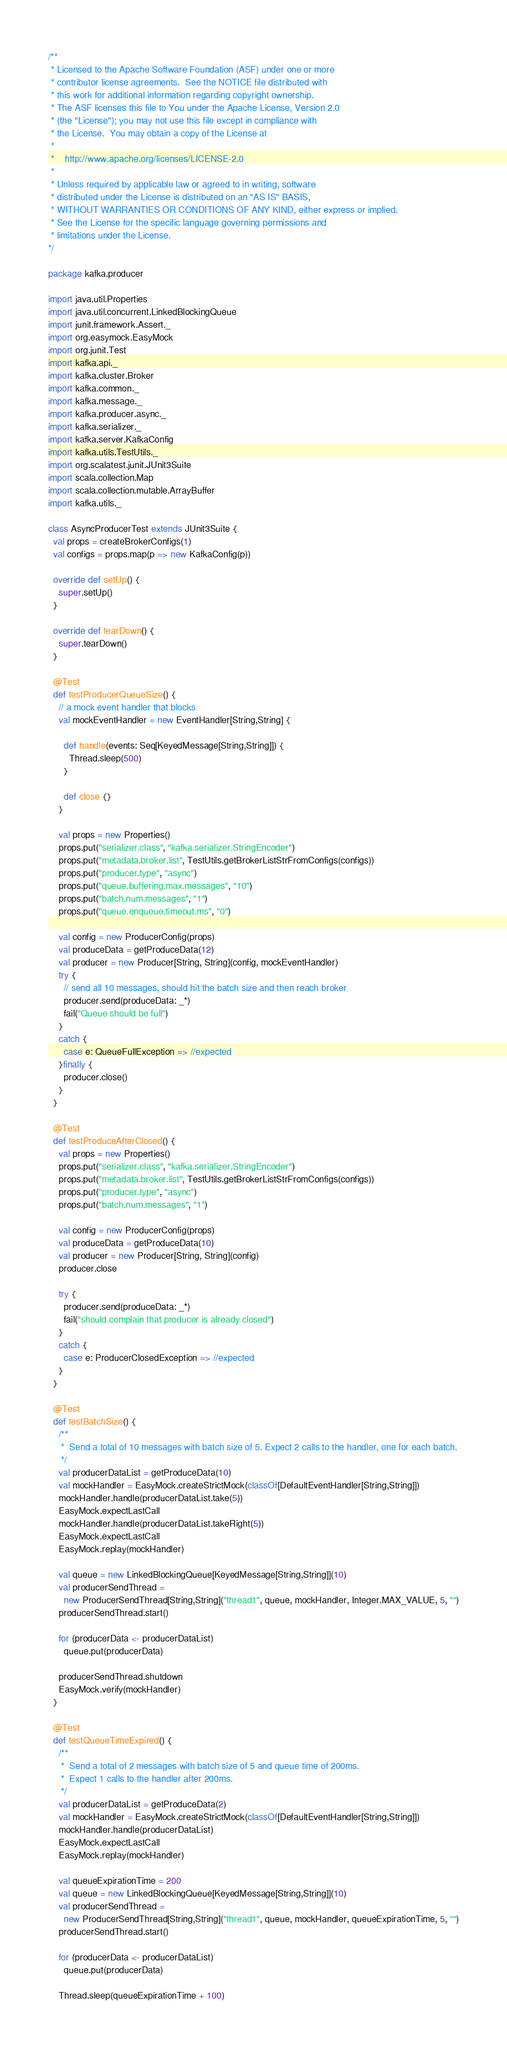Convert code to text. <code><loc_0><loc_0><loc_500><loc_500><_Scala_>/**
 * Licensed to the Apache Software Foundation (ASF) under one or more
 * contributor license agreements.  See the NOTICE file distributed with
 * this work for additional information regarding copyright ownership.
 * The ASF licenses this file to You under the Apache License, Version 2.0
 * (the "License"); you may not use this file except in compliance with
 * the License.  You may obtain a copy of the License at
 *
 *    http://www.apache.org/licenses/LICENSE-2.0
 *
 * Unless required by applicable law or agreed to in writing, software
 * distributed under the License is distributed on an "AS IS" BASIS,
 * WITHOUT WARRANTIES OR CONDITIONS OF ANY KIND, either express or implied.
 * See the License for the specific language governing permissions and
 * limitations under the License.
*/

package kafka.producer

import java.util.Properties
import java.util.concurrent.LinkedBlockingQueue
import junit.framework.Assert._
import org.easymock.EasyMock
import org.junit.Test
import kafka.api._
import kafka.cluster.Broker
import kafka.common._
import kafka.message._
import kafka.producer.async._
import kafka.serializer._
import kafka.server.KafkaConfig
import kafka.utils.TestUtils._
import org.scalatest.junit.JUnit3Suite
import scala.collection.Map
import scala.collection.mutable.ArrayBuffer
import kafka.utils._

class AsyncProducerTest extends JUnit3Suite {
  val props = createBrokerConfigs(1)
  val configs = props.map(p => new KafkaConfig(p))

  override def setUp() {
    super.setUp()
  }

  override def tearDown() {
    super.tearDown()
  }

  @Test
  def testProducerQueueSize() {
    // a mock event handler that blocks
    val mockEventHandler = new EventHandler[String,String] {

      def handle(events: Seq[KeyedMessage[String,String]]) {
        Thread.sleep(500)
      }

      def close {}
    }

    val props = new Properties()
    props.put("serializer.class", "kafka.serializer.StringEncoder")
    props.put("metadata.broker.list", TestUtils.getBrokerListStrFromConfigs(configs))
    props.put("producer.type", "async")
    props.put("queue.buffering.max.messages", "10")
    props.put("batch.num.messages", "1")
    props.put("queue.enqueue.timeout.ms", "0")

    val config = new ProducerConfig(props)
    val produceData = getProduceData(12)
    val producer = new Producer[String, String](config, mockEventHandler)
    try {
      // send all 10 messages, should hit the batch size and then reach broker
      producer.send(produceData: _*)
      fail("Queue should be full")
    }
    catch {
      case e: QueueFullException => //expected
    }finally {
      producer.close()
    }
  }

  @Test
  def testProduceAfterClosed() {
    val props = new Properties()
    props.put("serializer.class", "kafka.serializer.StringEncoder")
    props.put("metadata.broker.list", TestUtils.getBrokerListStrFromConfigs(configs))
    props.put("producer.type", "async")
    props.put("batch.num.messages", "1")

    val config = new ProducerConfig(props)
    val produceData = getProduceData(10)
    val producer = new Producer[String, String](config)
    producer.close

    try {
      producer.send(produceData: _*)
      fail("should complain that producer is already closed")
    }
    catch {
      case e: ProducerClosedException => //expected
    }
  }

  @Test
  def testBatchSize() {
    /**
     *  Send a total of 10 messages with batch size of 5. Expect 2 calls to the handler, one for each batch.
     */
    val producerDataList = getProduceData(10)
    val mockHandler = EasyMock.createStrictMock(classOf[DefaultEventHandler[String,String]])
    mockHandler.handle(producerDataList.take(5))
    EasyMock.expectLastCall
    mockHandler.handle(producerDataList.takeRight(5))
    EasyMock.expectLastCall
    EasyMock.replay(mockHandler)

    val queue = new LinkedBlockingQueue[KeyedMessage[String,String]](10)
    val producerSendThread =
      new ProducerSendThread[String,String]("thread1", queue, mockHandler, Integer.MAX_VALUE, 5, "")
    producerSendThread.start()

    for (producerData <- producerDataList)
      queue.put(producerData)

    producerSendThread.shutdown
    EasyMock.verify(mockHandler)
  }

  @Test
  def testQueueTimeExpired() {
    /**
     *  Send a total of 2 messages with batch size of 5 and queue time of 200ms.
     *  Expect 1 calls to the handler after 200ms.
     */
    val producerDataList = getProduceData(2)
    val mockHandler = EasyMock.createStrictMock(classOf[DefaultEventHandler[String,String]])
    mockHandler.handle(producerDataList)
    EasyMock.expectLastCall
    EasyMock.replay(mockHandler)

    val queueExpirationTime = 200
    val queue = new LinkedBlockingQueue[KeyedMessage[String,String]](10)
    val producerSendThread =
      new ProducerSendThread[String,String]("thread1", queue, mockHandler, queueExpirationTime, 5, "")
    producerSendThread.start()

    for (producerData <- producerDataList)
      queue.put(producerData)

    Thread.sleep(queueExpirationTime + 100)</code> 